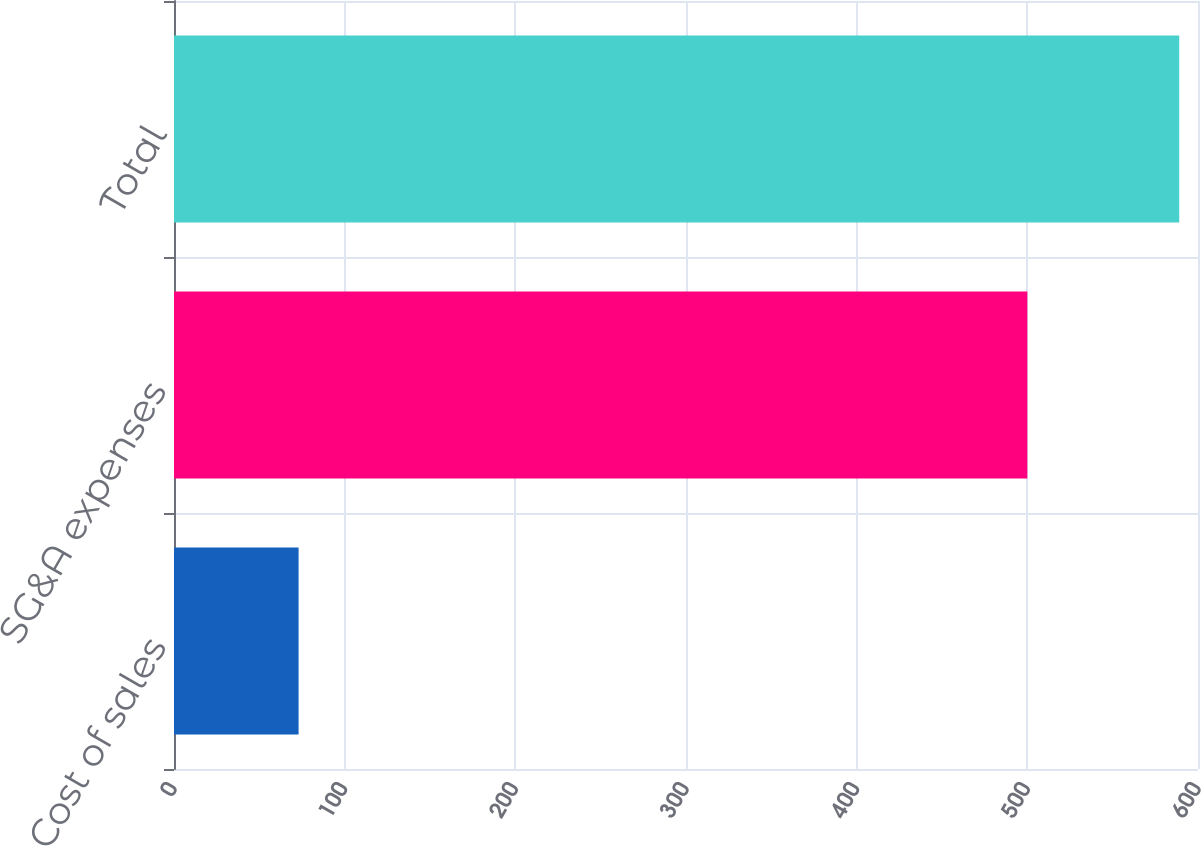Convert chart to OTSL. <chart><loc_0><loc_0><loc_500><loc_500><bar_chart><fcel>Cost of sales<fcel>SG&A expenses<fcel>Total<nl><fcel>73<fcel>500<fcel>589<nl></chart> 